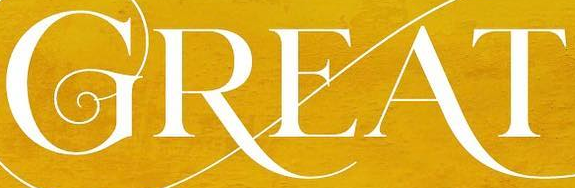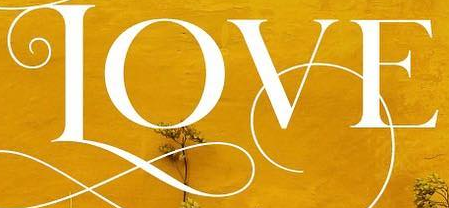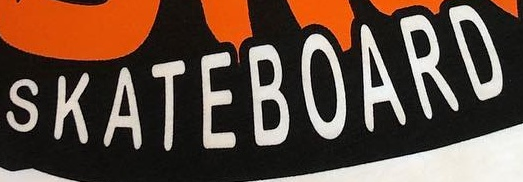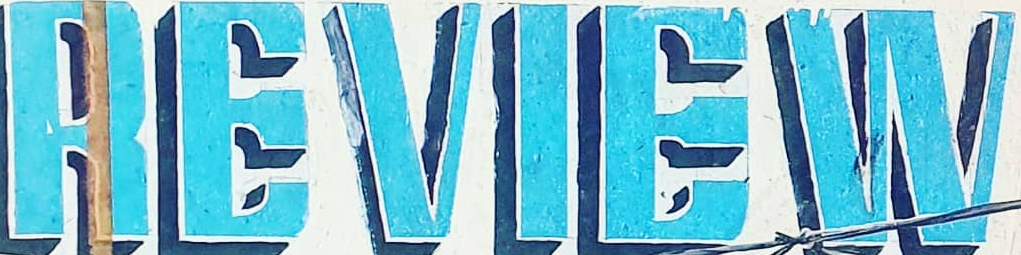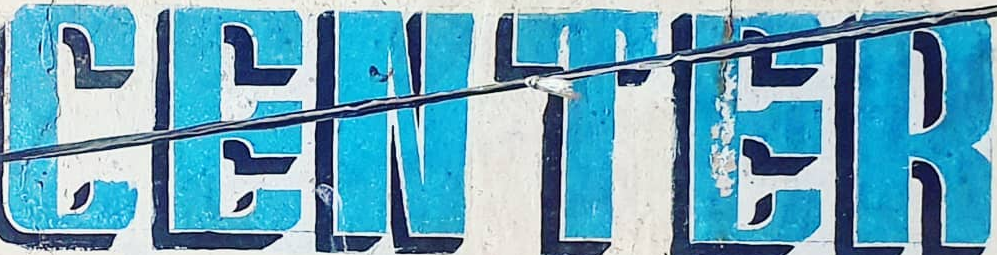Read the text content from these images in order, separated by a semicolon. GREAT; LOVE; SKATEBOARD; REVIEW; CENTER 